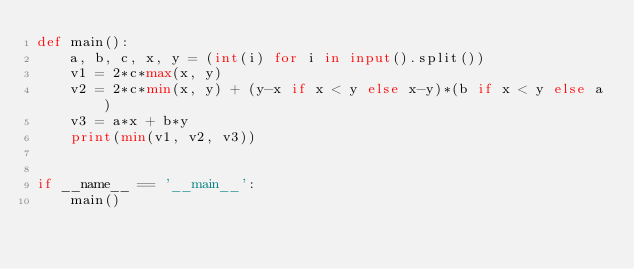Convert code to text. <code><loc_0><loc_0><loc_500><loc_500><_Python_>def main():
    a, b, c, x, y = (int(i) for i in input().split())
    v1 = 2*c*max(x, y)
    v2 = 2*c*min(x, y) + (y-x if x < y else x-y)*(b if x < y else a)
    v3 = a*x + b*y
    print(min(v1, v2, v3))


if __name__ == '__main__':
    main()
</code> 